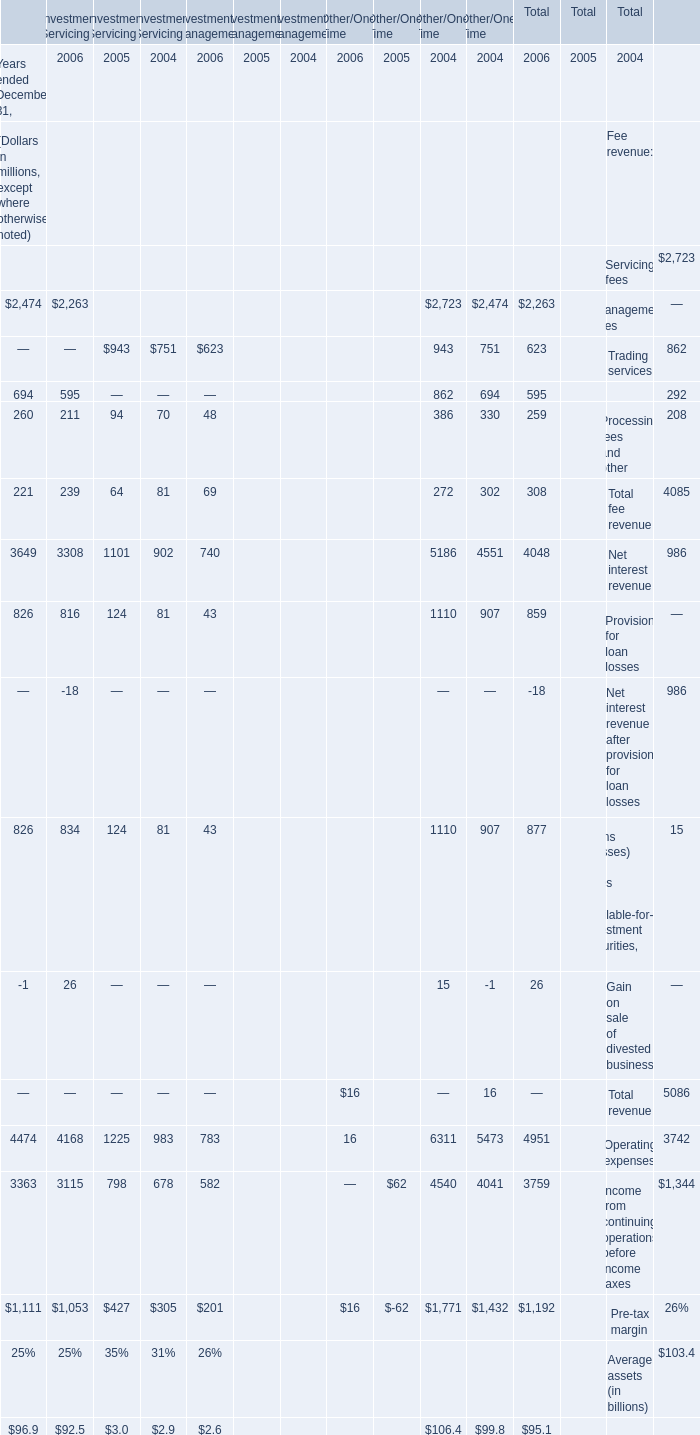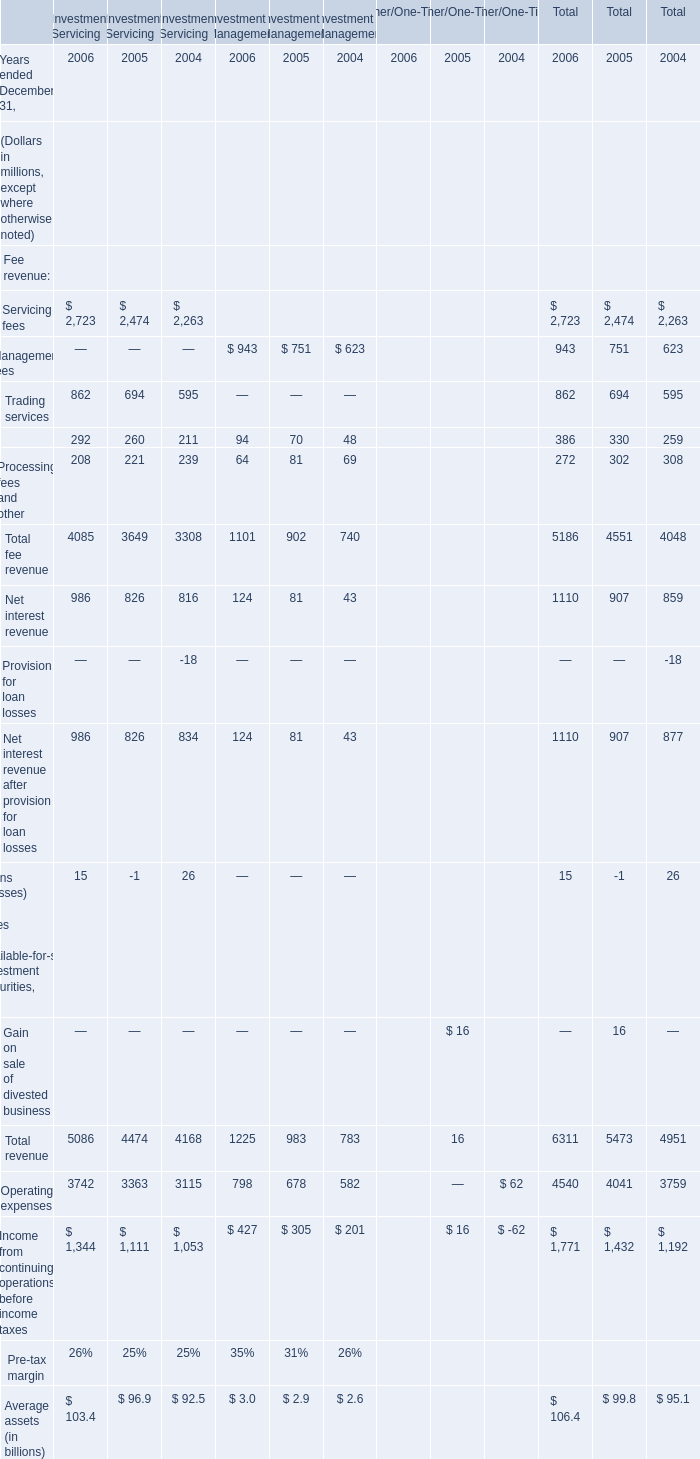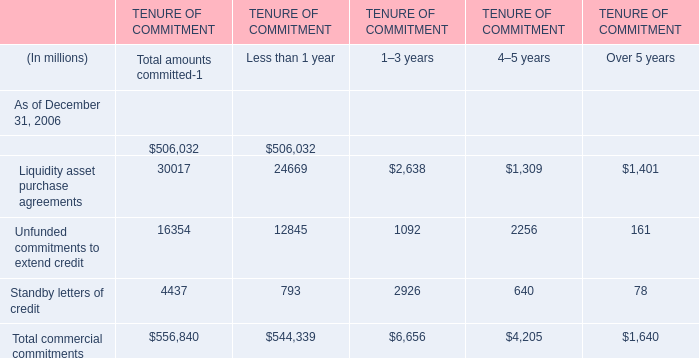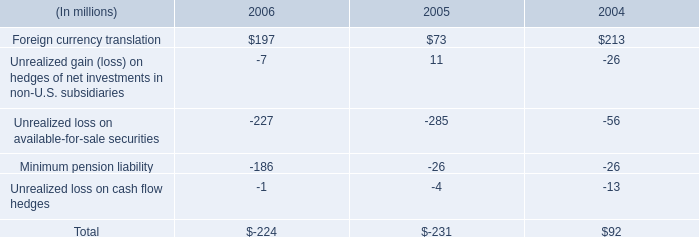In what year is Processing fees and other for investment management greater than 80? 
Answer: 2005. 